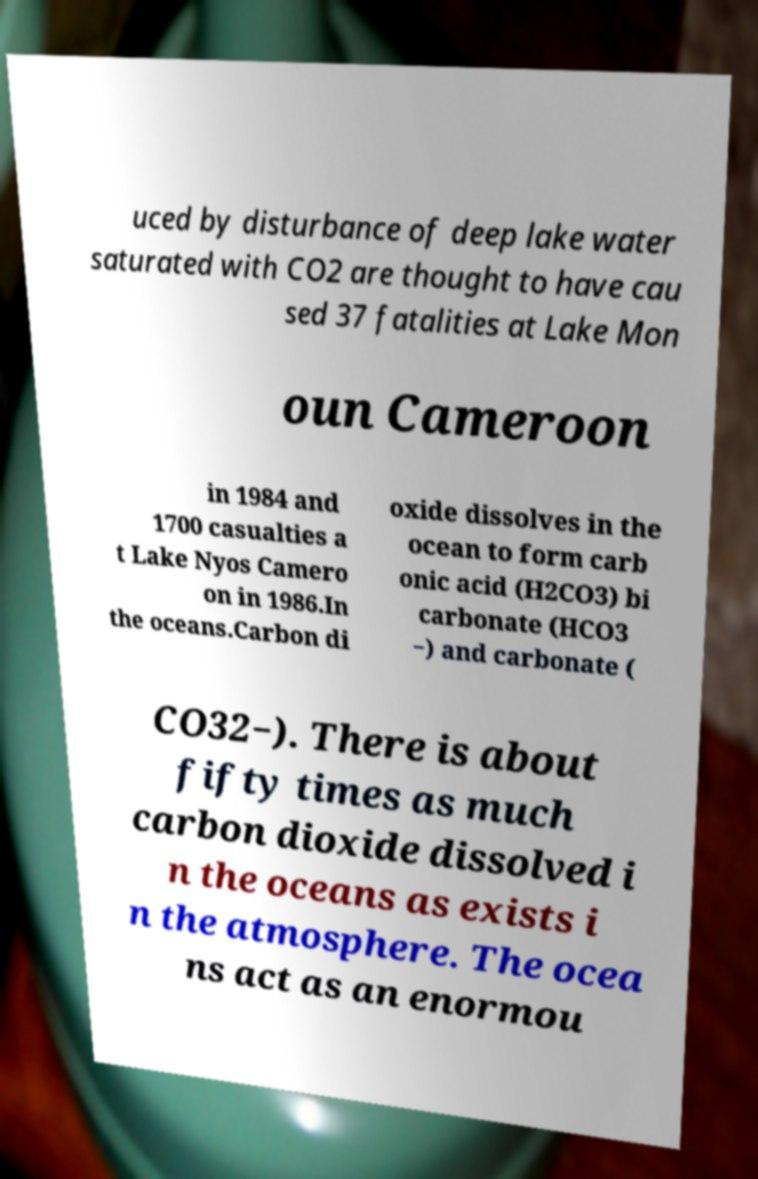There's text embedded in this image that I need extracted. Can you transcribe it verbatim? uced by disturbance of deep lake water saturated with CO2 are thought to have cau sed 37 fatalities at Lake Mon oun Cameroon in 1984 and 1700 casualties a t Lake Nyos Camero on in 1986.In the oceans.Carbon di oxide dissolves in the ocean to form carb onic acid (H2CO3) bi carbonate (HCO3 −) and carbonate ( CO32−). There is about fifty times as much carbon dioxide dissolved i n the oceans as exists i n the atmosphere. The ocea ns act as an enormou 